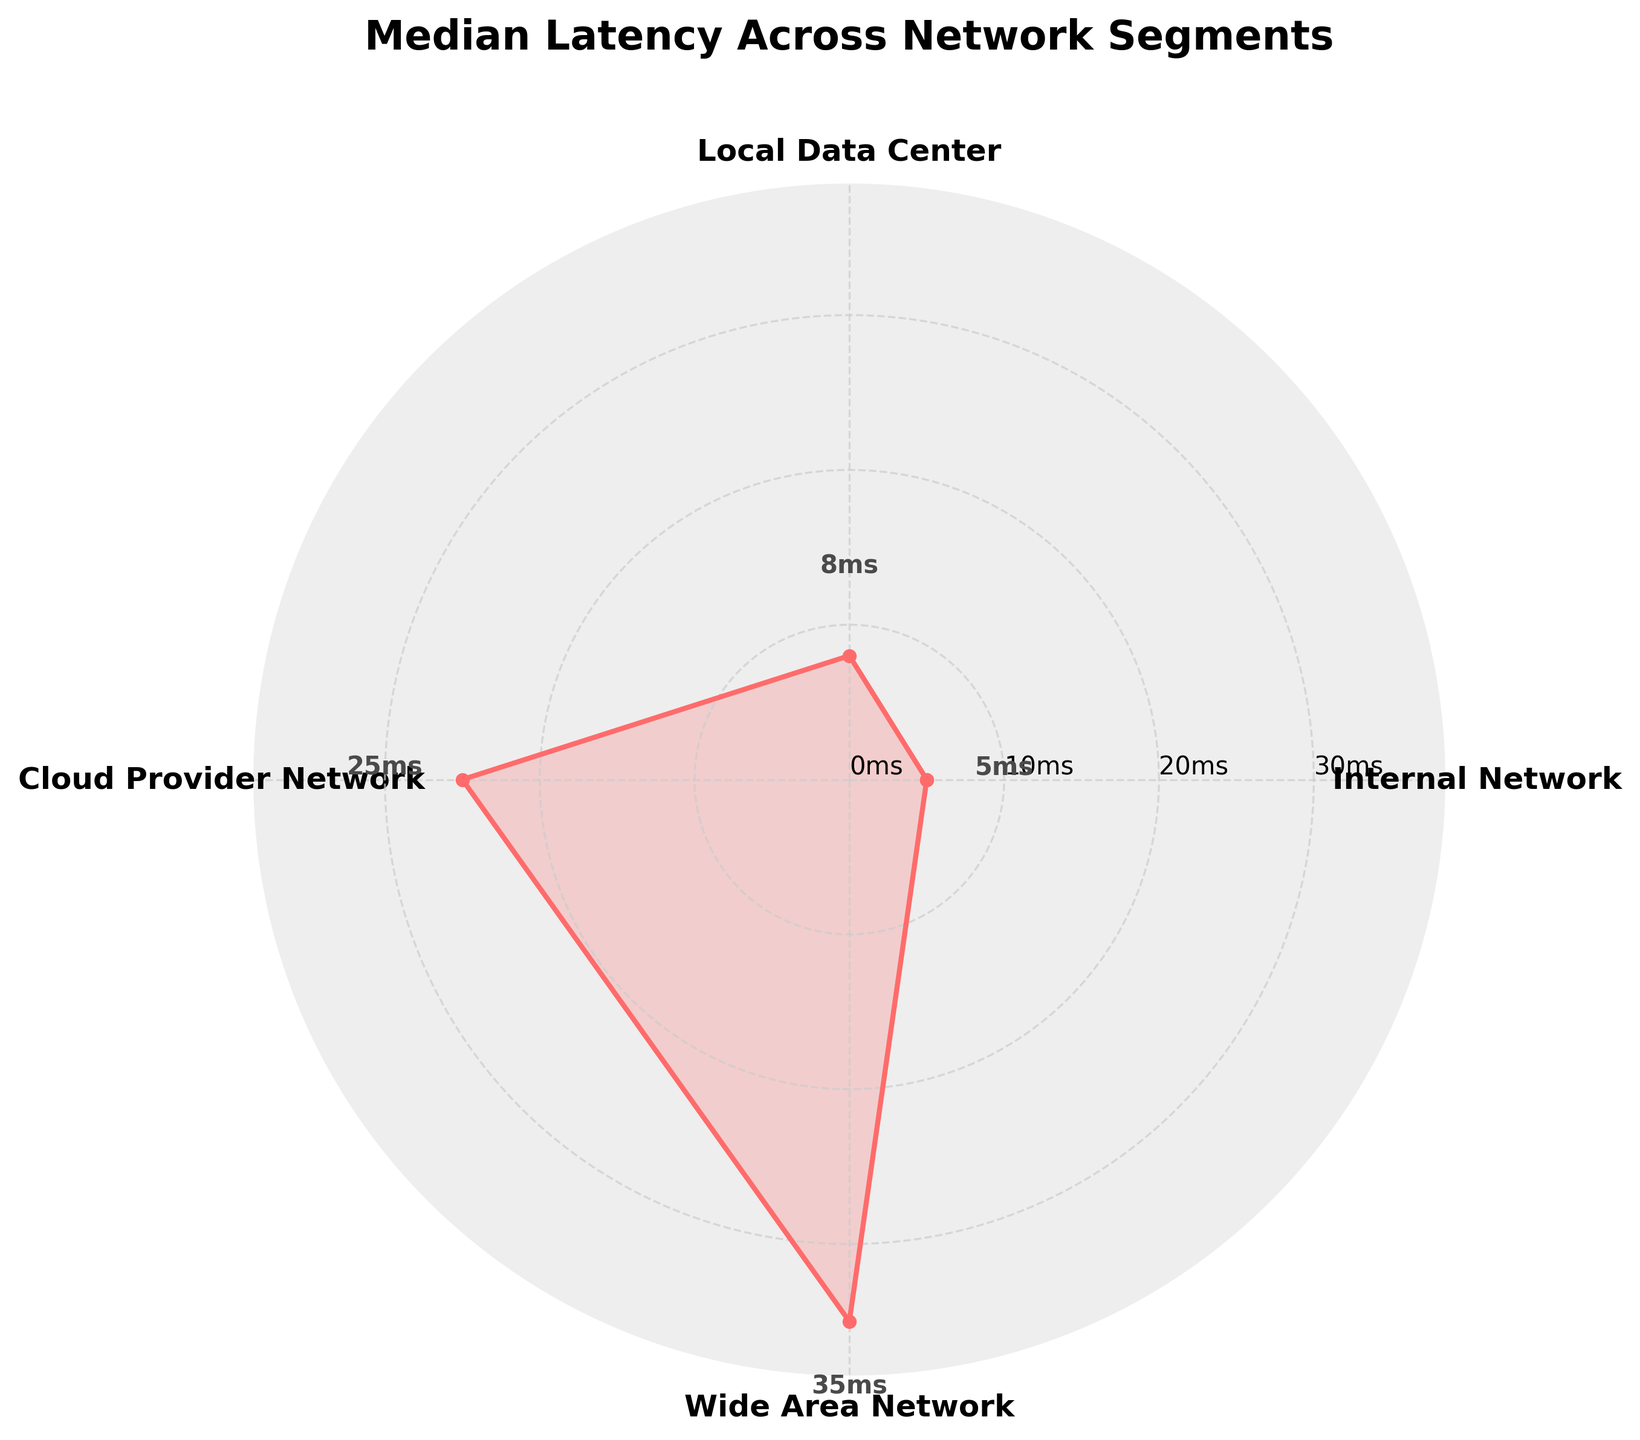What is the title of the figure? The title of the figure is usually displayed at the top and describes the content of the chart. In this case, the title is placed prominently above the rose chart.
Answer: Median Latency Across Network Segments How many network segments are displayed in the chart? Each category or group in the rose chart represents a network segment. By counting the number of segments, we can determine the total number displayed.
Answer: 4 Which network segment has the highest median latency? The highest median latency is shown as the outermost point on the rose chart. By comparing the values, we can identify that segment.
Answer: Wide Area Network What is the median latency for the Internal Network segment? The median latencies are annotated near each data point on the rose chart. Locate the annotation near the Internal Network segment.
Answer: 5 ms Which network segment has a median latency greater than the Local Data Center segment? First, find the median latency of the Local Data Center segment (8 ms). Then, compare it with the other segments' median latencies to find any greater values.
Answer: Cloud Provider Network, Wide Area Network By how much does the median latency of the Cloud Provider Network exceed that of the Internal Network? To determine the difference, subtract the median latency of the Internal Network (5 ms) from the median latency of the Cloud Provider Network (25 ms).
Answer: 20 ms What is the range of observed latencies for the Local Data Center segment? The range can be calculated by subtracting the minimum latency from the maximum latency for the Local Data Center segment (25 ms - 2 ms).
Answer: 23 ms Which two network segments have median latencies closest to each other? Compare the annotated median latencies to find the two values that are numerically closest.
Answer: Internal Network and Local Data Center Is the median latency of the Wide Area Network segment less than the 90th percentile latency of the Local Data Center segment? The median latency of the Wide Area Network is 35 ms and the 90th percentile latency of the Local Data Center is 20 ms. Compare these values.
Answer: No, it is greater What is the difference in median latency between the network segment with the lowest median latency and the segment with the highest median latency? Identify the segments with the lowest (5 ms) and highest (35 ms) median latencies. The difference is the highest median latency minus the lowest median latency (35 ms - 5 ms).
Answer: 30 ms 